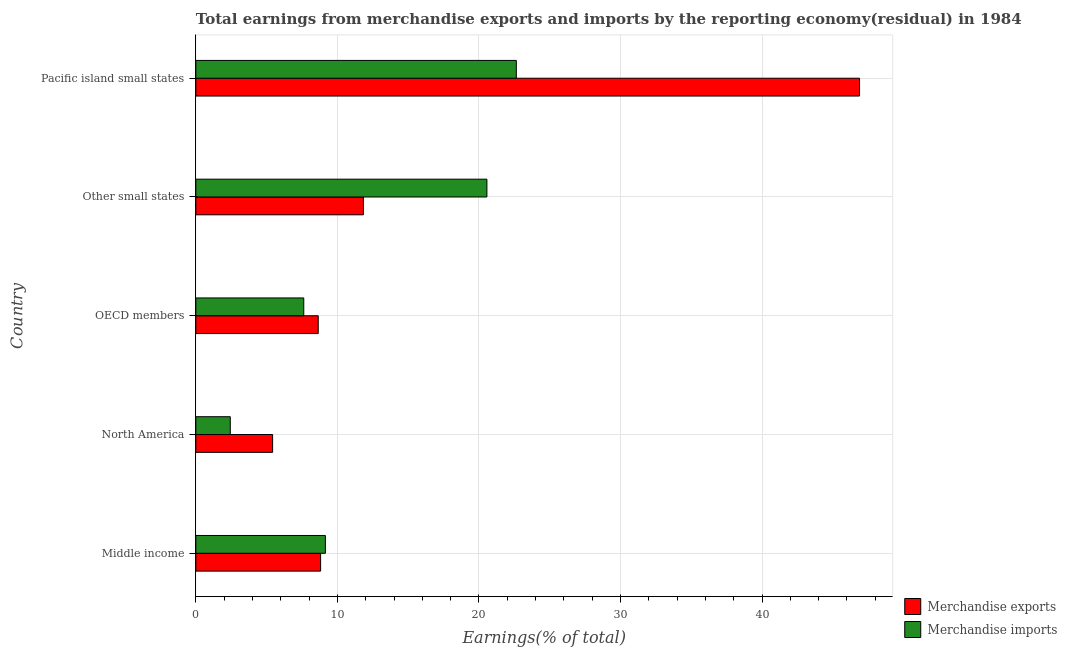Are the number of bars on each tick of the Y-axis equal?
Your response must be concise. Yes. How many bars are there on the 4th tick from the bottom?
Your answer should be compact. 2. In how many cases, is the number of bars for a given country not equal to the number of legend labels?
Give a very brief answer. 0. What is the earnings from merchandise exports in Other small states?
Give a very brief answer. 11.84. Across all countries, what is the maximum earnings from merchandise imports?
Your answer should be compact. 22.64. Across all countries, what is the minimum earnings from merchandise exports?
Your answer should be compact. 5.42. In which country was the earnings from merchandise imports maximum?
Make the answer very short. Pacific island small states. In which country was the earnings from merchandise exports minimum?
Make the answer very short. North America. What is the total earnings from merchandise exports in the graph?
Offer a very short reply. 81.61. What is the difference between the earnings from merchandise imports in Other small states and that in Pacific island small states?
Give a very brief answer. -2.08. What is the difference between the earnings from merchandise exports in Middle income and the earnings from merchandise imports in Other small states?
Make the answer very short. -11.75. What is the average earnings from merchandise imports per country?
Your response must be concise. 12.48. What is the difference between the earnings from merchandise imports and earnings from merchandise exports in Other small states?
Provide a succinct answer. 8.72. What is the ratio of the earnings from merchandise imports in North America to that in Pacific island small states?
Make the answer very short. 0.11. Is the difference between the earnings from merchandise imports in North America and OECD members greater than the difference between the earnings from merchandise exports in North America and OECD members?
Ensure brevity in your answer.  No. What is the difference between the highest and the second highest earnings from merchandise exports?
Your answer should be compact. 35.05. What is the difference between the highest and the lowest earnings from merchandise imports?
Ensure brevity in your answer.  20.21. Are all the bars in the graph horizontal?
Offer a very short reply. Yes. Are the values on the major ticks of X-axis written in scientific E-notation?
Your answer should be compact. No. Does the graph contain grids?
Provide a succinct answer. Yes. Where does the legend appear in the graph?
Your answer should be very brief. Bottom right. How many legend labels are there?
Provide a succinct answer. 2. What is the title of the graph?
Your response must be concise. Total earnings from merchandise exports and imports by the reporting economy(residual) in 1984. Does "Constant 2005 US$" appear as one of the legend labels in the graph?
Offer a very short reply. No. What is the label or title of the X-axis?
Ensure brevity in your answer.  Earnings(% of total). What is the Earnings(% of total) of Merchandise exports in Middle income?
Provide a short and direct response. 8.82. What is the Earnings(% of total) of Merchandise imports in Middle income?
Offer a terse response. 9.15. What is the Earnings(% of total) in Merchandise exports in North America?
Ensure brevity in your answer.  5.42. What is the Earnings(% of total) in Merchandise imports in North America?
Offer a terse response. 2.43. What is the Earnings(% of total) of Merchandise exports in OECD members?
Your answer should be very brief. 8.65. What is the Earnings(% of total) in Merchandise imports in OECD members?
Offer a very short reply. 7.63. What is the Earnings(% of total) of Merchandise exports in Other small states?
Give a very brief answer. 11.84. What is the Earnings(% of total) of Merchandise imports in Other small states?
Your response must be concise. 20.56. What is the Earnings(% of total) in Merchandise exports in Pacific island small states?
Your answer should be compact. 46.89. What is the Earnings(% of total) in Merchandise imports in Pacific island small states?
Make the answer very short. 22.64. Across all countries, what is the maximum Earnings(% of total) of Merchandise exports?
Your answer should be compact. 46.89. Across all countries, what is the maximum Earnings(% of total) of Merchandise imports?
Make the answer very short. 22.64. Across all countries, what is the minimum Earnings(% of total) in Merchandise exports?
Your answer should be compact. 5.42. Across all countries, what is the minimum Earnings(% of total) in Merchandise imports?
Provide a succinct answer. 2.43. What is the total Earnings(% of total) in Merchandise exports in the graph?
Make the answer very short. 81.61. What is the total Earnings(% of total) of Merchandise imports in the graph?
Give a very brief answer. 62.42. What is the difference between the Earnings(% of total) in Merchandise exports in Middle income and that in North America?
Keep it short and to the point. 3.39. What is the difference between the Earnings(% of total) in Merchandise imports in Middle income and that in North America?
Make the answer very short. 6.72. What is the difference between the Earnings(% of total) in Merchandise exports in Middle income and that in OECD members?
Make the answer very short. 0.17. What is the difference between the Earnings(% of total) in Merchandise imports in Middle income and that in OECD members?
Keep it short and to the point. 1.53. What is the difference between the Earnings(% of total) of Merchandise exports in Middle income and that in Other small states?
Your answer should be compact. -3.02. What is the difference between the Earnings(% of total) in Merchandise imports in Middle income and that in Other small states?
Provide a short and direct response. -11.41. What is the difference between the Earnings(% of total) in Merchandise exports in Middle income and that in Pacific island small states?
Offer a very short reply. -38.07. What is the difference between the Earnings(% of total) of Merchandise imports in Middle income and that in Pacific island small states?
Offer a terse response. -13.49. What is the difference between the Earnings(% of total) of Merchandise exports in North America and that in OECD members?
Give a very brief answer. -3.22. What is the difference between the Earnings(% of total) of Merchandise imports in North America and that in OECD members?
Your response must be concise. -5.19. What is the difference between the Earnings(% of total) in Merchandise exports in North America and that in Other small states?
Provide a short and direct response. -6.42. What is the difference between the Earnings(% of total) in Merchandise imports in North America and that in Other small states?
Provide a short and direct response. -18.13. What is the difference between the Earnings(% of total) in Merchandise exports in North America and that in Pacific island small states?
Offer a very short reply. -41.46. What is the difference between the Earnings(% of total) in Merchandise imports in North America and that in Pacific island small states?
Provide a short and direct response. -20.21. What is the difference between the Earnings(% of total) of Merchandise exports in OECD members and that in Other small states?
Ensure brevity in your answer.  -3.19. What is the difference between the Earnings(% of total) in Merchandise imports in OECD members and that in Other small states?
Your answer should be compact. -12.94. What is the difference between the Earnings(% of total) of Merchandise exports in OECD members and that in Pacific island small states?
Your answer should be compact. -38.24. What is the difference between the Earnings(% of total) in Merchandise imports in OECD members and that in Pacific island small states?
Your response must be concise. -15.02. What is the difference between the Earnings(% of total) in Merchandise exports in Other small states and that in Pacific island small states?
Make the answer very short. -35.05. What is the difference between the Earnings(% of total) of Merchandise imports in Other small states and that in Pacific island small states?
Give a very brief answer. -2.08. What is the difference between the Earnings(% of total) of Merchandise exports in Middle income and the Earnings(% of total) of Merchandise imports in North America?
Make the answer very short. 6.38. What is the difference between the Earnings(% of total) of Merchandise exports in Middle income and the Earnings(% of total) of Merchandise imports in OECD members?
Provide a succinct answer. 1.19. What is the difference between the Earnings(% of total) in Merchandise exports in Middle income and the Earnings(% of total) in Merchandise imports in Other small states?
Provide a succinct answer. -11.75. What is the difference between the Earnings(% of total) of Merchandise exports in Middle income and the Earnings(% of total) of Merchandise imports in Pacific island small states?
Make the answer very short. -13.83. What is the difference between the Earnings(% of total) of Merchandise exports in North America and the Earnings(% of total) of Merchandise imports in OECD members?
Your answer should be compact. -2.2. What is the difference between the Earnings(% of total) of Merchandise exports in North America and the Earnings(% of total) of Merchandise imports in Other small states?
Your response must be concise. -15.14. What is the difference between the Earnings(% of total) in Merchandise exports in North America and the Earnings(% of total) in Merchandise imports in Pacific island small states?
Your answer should be compact. -17.22. What is the difference between the Earnings(% of total) of Merchandise exports in OECD members and the Earnings(% of total) of Merchandise imports in Other small states?
Give a very brief answer. -11.92. What is the difference between the Earnings(% of total) of Merchandise exports in OECD members and the Earnings(% of total) of Merchandise imports in Pacific island small states?
Provide a succinct answer. -13.99. What is the difference between the Earnings(% of total) in Merchandise exports in Other small states and the Earnings(% of total) in Merchandise imports in Pacific island small states?
Your answer should be compact. -10.8. What is the average Earnings(% of total) of Merchandise exports per country?
Offer a very short reply. 16.32. What is the average Earnings(% of total) of Merchandise imports per country?
Offer a terse response. 12.48. What is the difference between the Earnings(% of total) of Merchandise exports and Earnings(% of total) of Merchandise imports in Middle income?
Your answer should be compact. -0.34. What is the difference between the Earnings(% of total) in Merchandise exports and Earnings(% of total) in Merchandise imports in North America?
Your answer should be very brief. 2.99. What is the difference between the Earnings(% of total) in Merchandise exports and Earnings(% of total) in Merchandise imports in OECD members?
Your answer should be very brief. 1.02. What is the difference between the Earnings(% of total) of Merchandise exports and Earnings(% of total) of Merchandise imports in Other small states?
Give a very brief answer. -8.72. What is the difference between the Earnings(% of total) of Merchandise exports and Earnings(% of total) of Merchandise imports in Pacific island small states?
Provide a succinct answer. 24.25. What is the ratio of the Earnings(% of total) of Merchandise exports in Middle income to that in North America?
Your answer should be compact. 1.63. What is the ratio of the Earnings(% of total) in Merchandise imports in Middle income to that in North America?
Provide a succinct answer. 3.76. What is the ratio of the Earnings(% of total) of Merchandise exports in Middle income to that in OECD members?
Your answer should be compact. 1.02. What is the ratio of the Earnings(% of total) of Merchandise imports in Middle income to that in OECD members?
Your answer should be very brief. 1.2. What is the ratio of the Earnings(% of total) in Merchandise exports in Middle income to that in Other small states?
Offer a very short reply. 0.74. What is the ratio of the Earnings(% of total) of Merchandise imports in Middle income to that in Other small states?
Provide a succinct answer. 0.45. What is the ratio of the Earnings(% of total) in Merchandise exports in Middle income to that in Pacific island small states?
Provide a short and direct response. 0.19. What is the ratio of the Earnings(% of total) of Merchandise imports in Middle income to that in Pacific island small states?
Your answer should be compact. 0.4. What is the ratio of the Earnings(% of total) of Merchandise exports in North America to that in OECD members?
Your answer should be very brief. 0.63. What is the ratio of the Earnings(% of total) of Merchandise imports in North America to that in OECD members?
Offer a very short reply. 0.32. What is the ratio of the Earnings(% of total) in Merchandise exports in North America to that in Other small states?
Your answer should be very brief. 0.46. What is the ratio of the Earnings(% of total) of Merchandise imports in North America to that in Other small states?
Your response must be concise. 0.12. What is the ratio of the Earnings(% of total) in Merchandise exports in North America to that in Pacific island small states?
Provide a succinct answer. 0.12. What is the ratio of the Earnings(% of total) of Merchandise imports in North America to that in Pacific island small states?
Provide a succinct answer. 0.11. What is the ratio of the Earnings(% of total) in Merchandise exports in OECD members to that in Other small states?
Your response must be concise. 0.73. What is the ratio of the Earnings(% of total) in Merchandise imports in OECD members to that in Other small states?
Your response must be concise. 0.37. What is the ratio of the Earnings(% of total) in Merchandise exports in OECD members to that in Pacific island small states?
Make the answer very short. 0.18. What is the ratio of the Earnings(% of total) of Merchandise imports in OECD members to that in Pacific island small states?
Keep it short and to the point. 0.34. What is the ratio of the Earnings(% of total) in Merchandise exports in Other small states to that in Pacific island small states?
Keep it short and to the point. 0.25. What is the ratio of the Earnings(% of total) in Merchandise imports in Other small states to that in Pacific island small states?
Your answer should be very brief. 0.91. What is the difference between the highest and the second highest Earnings(% of total) of Merchandise exports?
Give a very brief answer. 35.05. What is the difference between the highest and the second highest Earnings(% of total) in Merchandise imports?
Provide a short and direct response. 2.08. What is the difference between the highest and the lowest Earnings(% of total) in Merchandise exports?
Provide a short and direct response. 41.46. What is the difference between the highest and the lowest Earnings(% of total) of Merchandise imports?
Keep it short and to the point. 20.21. 